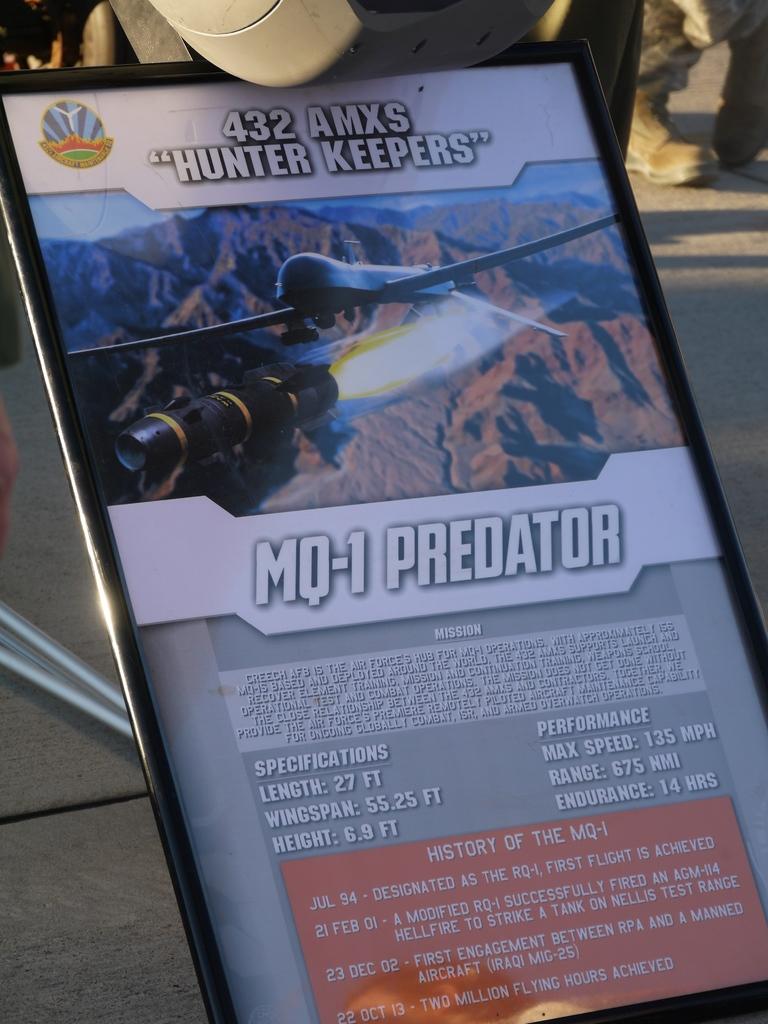What is the length of the mq-1 predator?
Provide a succinct answer. 27 ft. How many are hunter keepers?
Make the answer very short. 432. 